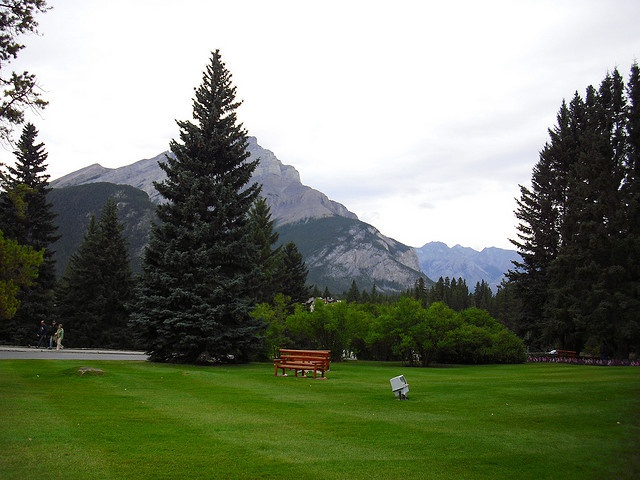Describe the objects in this image and their specific colors. I can see bench in lightblue, maroon, black, gray, and brown tones, people in lightblue, black, gray, and maroon tones, people in lightblue, gray, black, darkgreen, and darkgray tones, and people in lightblue, black, and gray tones in this image. 